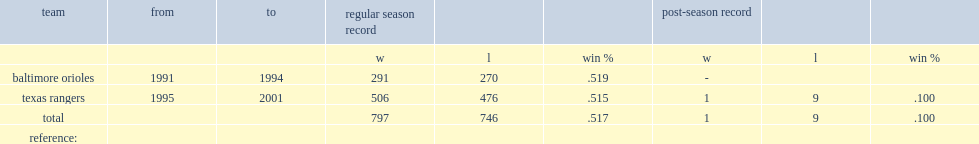What was the managerial record(wins and losses) of johnny oates with rangers? 506.0 476.0. 